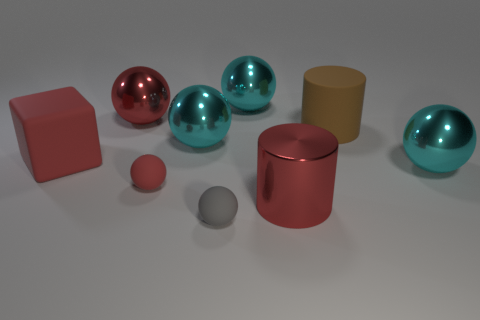Is the number of red rubber cubes that are behind the large brown cylinder less than the number of big shiny things left of the tiny gray matte thing?
Make the answer very short. Yes. Is the red thing that is right of the small red object made of the same material as the cyan object that is left of the gray ball?
Provide a short and direct response. Yes. What is the shape of the large brown rubber object?
Provide a succinct answer. Cylinder. Are there more red objects behind the big red metallic cylinder than red cylinders left of the big rubber cylinder?
Ensure brevity in your answer.  Yes. There is a large red thing that is behind the large red cube; does it have the same shape as the cyan metal thing on the right side of the brown rubber thing?
Offer a very short reply. Yes. What number of other things are there of the same size as the gray sphere?
Provide a short and direct response. 1. What size is the cube?
Your answer should be very brief. Large. Is the brown cylinder behind the big cube made of the same material as the small gray ball?
Make the answer very short. Yes. What is the color of the other matte thing that is the same shape as the tiny red thing?
Your answer should be very brief. Gray. Do the cylinder in front of the large red block and the big cube have the same color?
Ensure brevity in your answer.  Yes. 